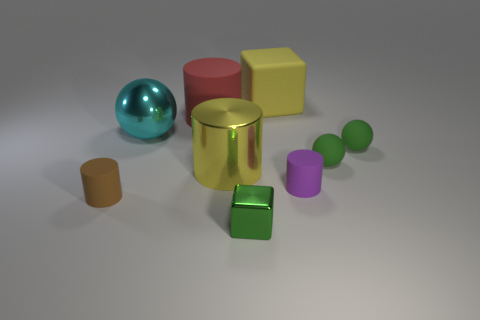What number of balls are tiny purple metal objects or rubber objects?
Keep it short and to the point. 2. Do the large cyan sphere and the brown cylinder have the same material?
Offer a very short reply. No. What number of other things are the same color as the big shiny cylinder?
Your answer should be very brief. 1. The rubber thing that is in front of the tiny purple cylinder has what shape?
Give a very brief answer. Cylinder. What number of things are either small purple rubber objects or gray cubes?
Keep it short and to the point. 1. There is a red matte object; does it have the same size as the yellow metal thing that is behind the brown object?
Provide a succinct answer. Yes. What number of other objects are there of the same material as the purple thing?
Provide a short and direct response. 5. What number of things are cylinders in front of the purple thing or shiny objects behind the purple object?
Offer a very short reply. 3. There is a tiny brown thing that is the same shape as the large red thing; what is it made of?
Provide a succinct answer. Rubber. Are any tiny red cubes visible?
Your answer should be compact. No. 